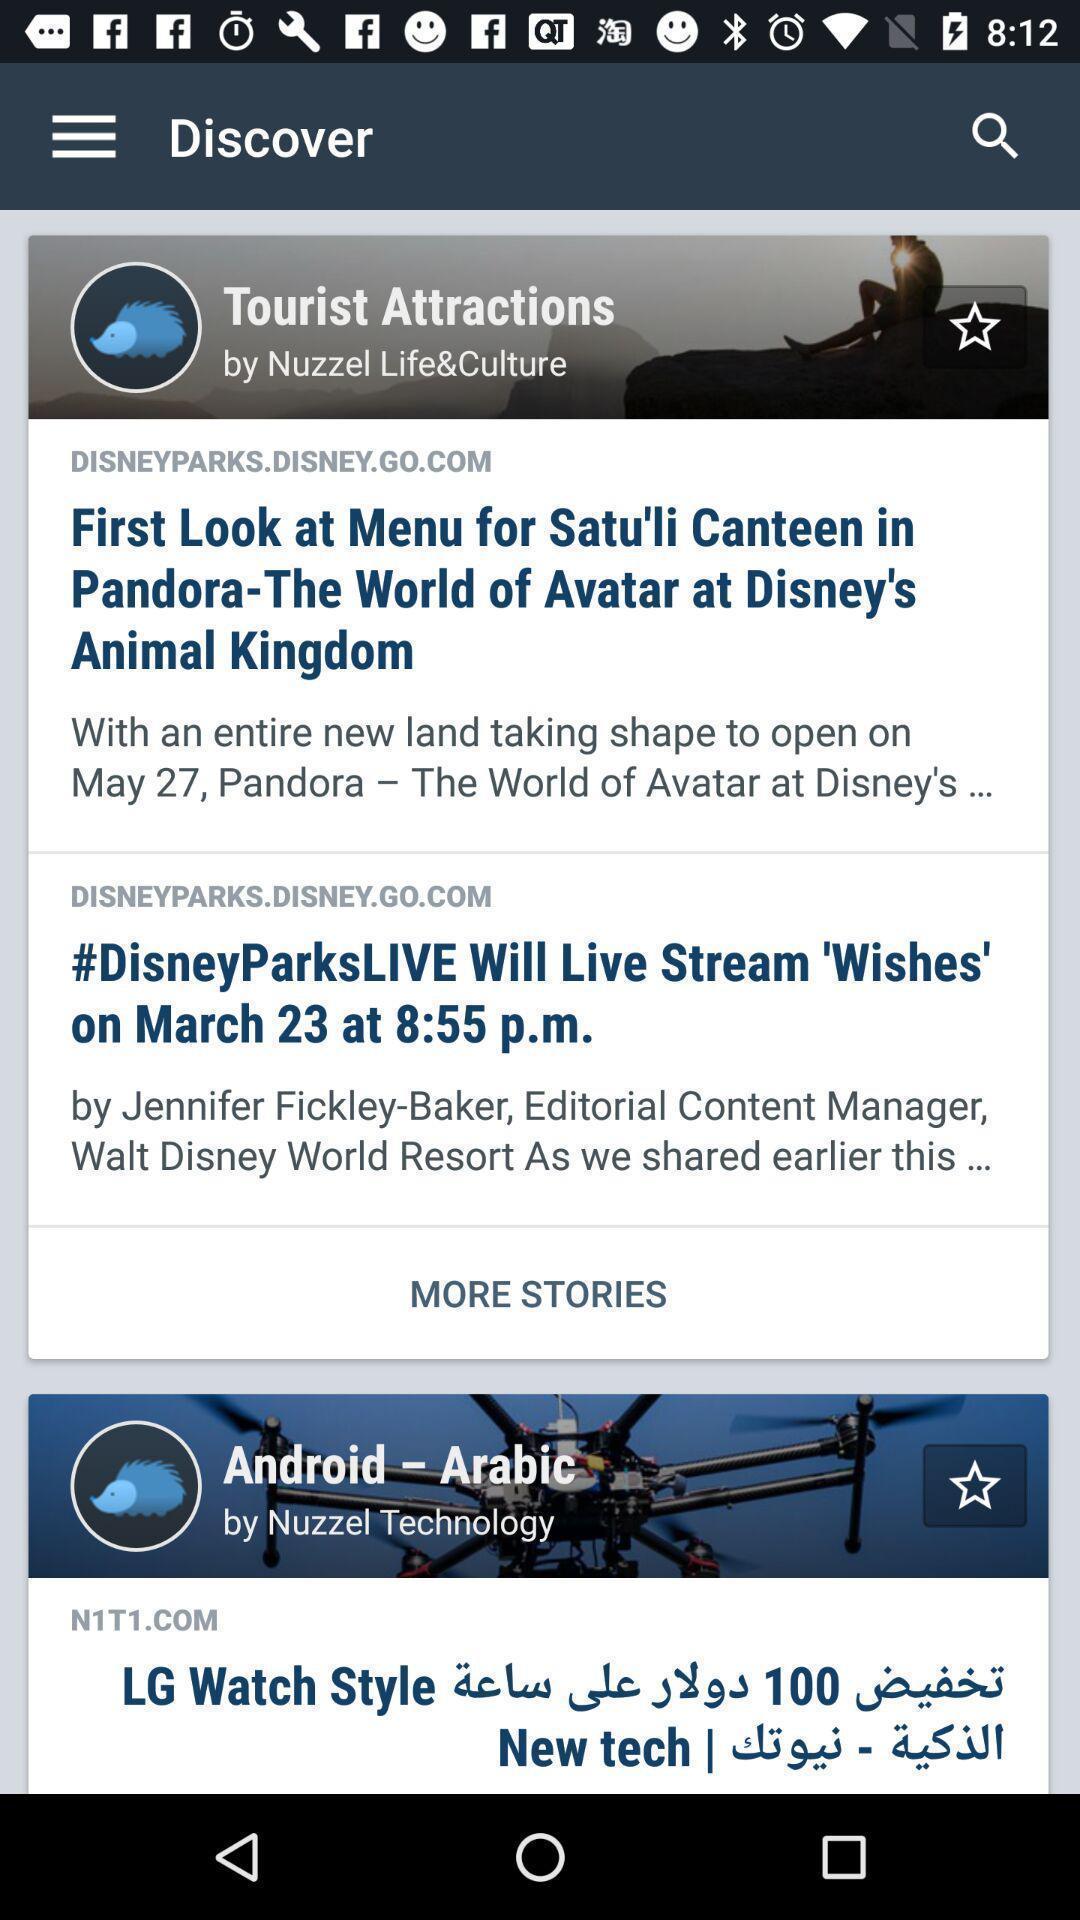What can you discern from this picture? Page showing articles in a tourist destination related app. 